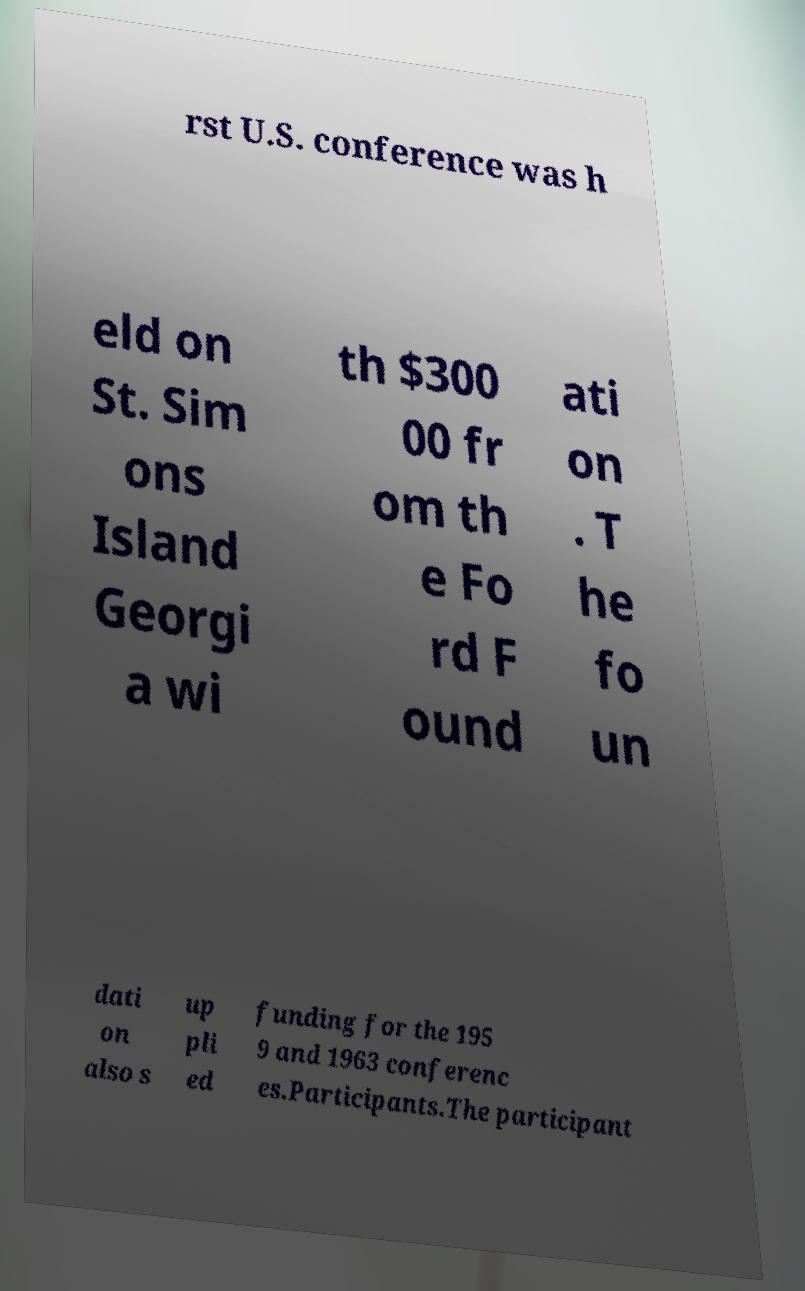Please read and relay the text visible in this image. What does it say? rst U.S. conference was h eld on St. Sim ons Island Georgi a wi th $300 00 fr om th e Fo rd F ound ati on . T he fo un dati on also s up pli ed funding for the 195 9 and 1963 conferenc es.Participants.The participant 